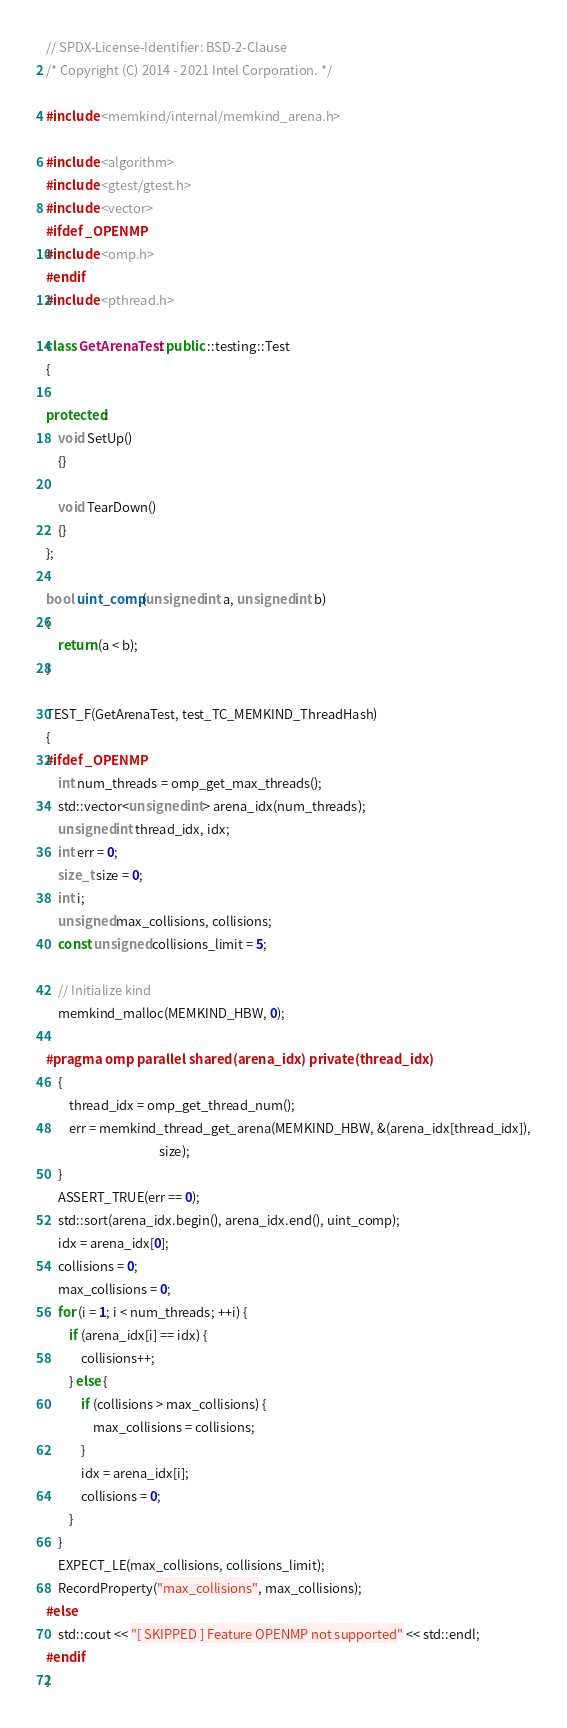<code> <loc_0><loc_0><loc_500><loc_500><_C++_>// SPDX-License-Identifier: BSD-2-Clause
/* Copyright (C) 2014 - 2021 Intel Corporation. */

#include <memkind/internal/memkind_arena.h>

#include <algorithm>
#include <gtest/gtest.h>
#include <vector>
#ifdef _OPENMP
#include <omp.h>
#endif
#include <pthread.h>

class GetArenaTest: public ::testing::Test
{

protected:
    void SetUp()
    {}

    void TearDown()
    {}
};

bool uint_comp(unsigned int a, unsigned int b)
{
    return (a < b);
}

TEST_F(GetArenaTest, test_TC_MEMKIND_ThreadHash)
{
#ifdef _OPENMP
    int num_threads = omp_get_max_threads();
    std::vector<unsigned int> arena_idx(num_threads);
    unsigned int thread_idx, idx;
    int err = 0;
    size_t size = 0;
    int i;
    unsigned max_collisions, collisions;
    const unsigned collisions_limit = 5;

    // Initialize kind
    memkind_malloc(MEMKIND_HBW, 0);

#pragma omp parallel shared(arena_idx) private(thread_idx)
    {
        thread_idx = omp_get_thread_num();
        err = memkind_thread_get_arena(MEMKIND_HBW, &(arena_idx[thread_idx]),
                                       size);
    }
    ASSERT_TRUE(err == 0);
    std::sort(arena_idx.begin(), arena_idx.end(), uint_comp);
    idx = arena_idx[0];
    collisions = 0;
    max_collisions = 0;
    for (i = 1; i < num_threads; ++i) {
        if (arena_idx[i] == idx) {
            collisions++;
        } else {
            if (collisions > max_collisions) {
                max_collisions = collisions;
            }
            idx = arena_idx[i];
            collisions = 0;
        }
    }
    EXPECT_LE(max_collisions, collisions_limit);
    RecordProperty("max_collisions", max_collisions);
#else
    std::cout << "[ SKIPPED ] Feature OPENMP not supported" << std::endl;
#endif
}
</code> 